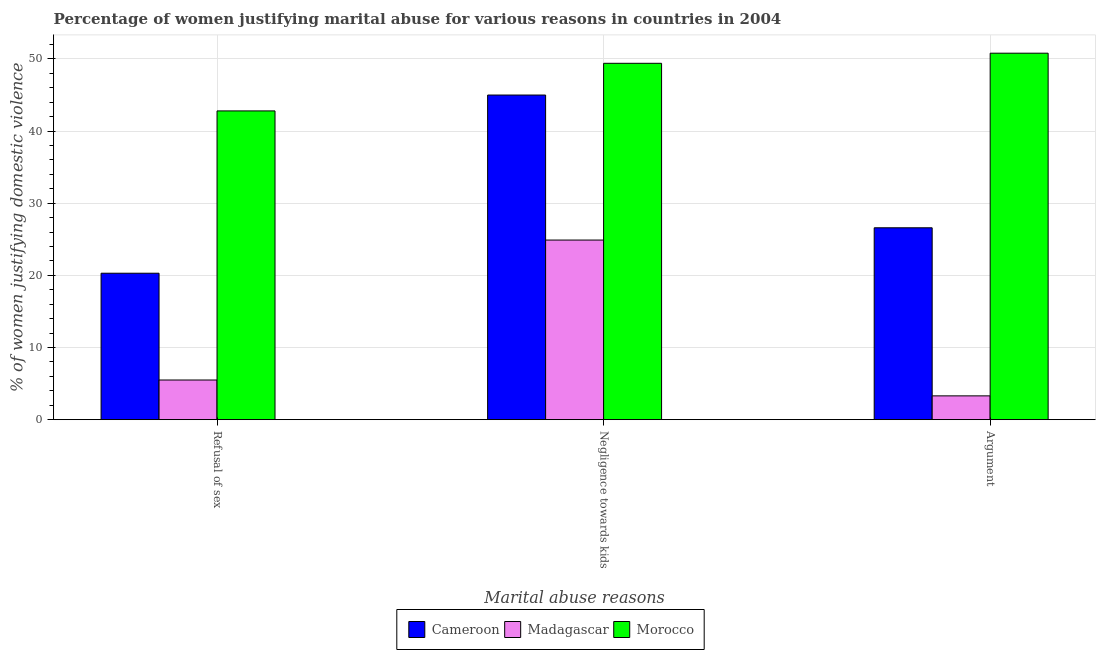How many different coloured bars are there?
Provide a short and direct response. 3. Are the number of bars on each tick of the X-axis equal?
Your answer should be very brief. Yes. How many bars are there on the 2nd tick from the left?
Your response must be concise. 3. How many bars are there on the 1st tick from the right?
Make the answer very short. 3. What is the label of the 2nd group of bars from the left?
Give a very brief answer. Negligence towards kids. What is the percentage of women justifying domestic violence due to arguments in Cameroon?
Your response must be concise. 26.6. Across all countries, what is the maximum percentage of women justifying domestic violence due to negligence towards kids?
Offer a terse response. 49.4. In which country was the percentage of women justifying domestic violence due to refusal of sex maximum?
Keep it short and to the point. Morocco. In which country was the percentage of women justifying domestic violence due to negligence towards kids minimum?
Offer a very short reply. Madagascar. What is the total percentage of women justifying domestic violence due to arguments in the graph?
Offer a terse response. 80.7. What is the difference between the percentage of women justifying domestic violence due to negligence towards kids in Madagascar and that in Cameroon?
Ensure brevity in your answer.  -20.1. What is the difference between the percentage of women justifying domestic violence due to refusal of sex in Cameroon and the percentage of women justifying domestic violence due to negligence towards kids in Madagascar?
Your answer should be compact. -4.6. What is the average percentage of women justifying domestic violence due to refusal of sex per country?
Give a very brief answer. 22.87. In how many countries, is the percentage of women justifying domestic violence due to negligence towards kids greater than 40 %?
Offer a very short reply. 2. What is the ratio of the percentage of women justifying domestic violence due to refusal of sex in Morocco to that in Cameroon?
Ensure brevity in your answer.  2.11. Is the difference between the percentage of women justifying domestic violence due to negligence towards kids in Madagascar and Morocco greater than the difference between the percentage of women justifying domestic violence due to arguments in Madagascar and Morocco?
Offer a terse response. Yes. What is the difference between the highest and the second highest percentage of women justifying domestic violence due to refusal of sex?
Your response must be concise. 22.5. In how many countries, is the percentage of women justifying domestic violence due to negligence towards kids greater than the average percentage of women justifying domestic violence due to negligence towards kids taken over all countries?
Your response must be concise. 2. What does the 1st bar from the left in Negligence towards kids represents?
Ensure brevity in your answer.  Cameroon. What does the 3rd bar from the right in Refusal of sex represents?
Provide a succinct answer. Cameroon. How many bars are there?
Ensure brevity in your answer.  9. Are all the bars in the graph horizontal?
Ensure brevity in your answer.  No. What is the difference between two consecutive major ticks on the Y-axis?
Provide a succinct answer. 10. Are the values on the major ticks of Y-axis written in scientific E-notation?
Offer a terse response. No. How many legend labels are there?
Give a very brief answer. 3. How are the legend labels stacked?
Your response must be concise. Horizontal. What is the title of the graph?
Your answer should be compact. Percentage of women justifying marital abuse for various reasons in countries in 2004. Does "Lao PDR" appear as one of the legend labels in the graph?
Your answer should be compact. No. What is the label or title of the X-axis?
Make the answer very short. Marital abuse reasons. What is the label or title of the Y-axis?
Your answer should be compact. % of women justifying domestic violence. What is the % of women justifying domestic violence of Cameroon in Refusal of sex?
Make the answer very short. 20.3. What is the % of women justifying domestic violence of Madagascar in Refusal of sex?
Your answer should be compact. 5.5. What is the % of women justifying domestic violence of Morocco in Refusal of sex?
Provide a succinct answer. 42.8. What is the % of women justifying domestic violence of Cameroon in Negligence towards kids?
Keep it short and to the point. 45. What is the % of women justifying domestic violence of Madagascar in Negligence towards kids?
Your response must be concise. 24.9. What is the % of women justifying domestic violence of Morocco in Negligence towards kids?
Your response must be concise. 49.4. What is the % of women justifying domestic violence in Cameroon in Argument?
Ensure brevity in your answer.  26.6. What is the % of women justifying domestic violence of Madagascar in Argument?
Your response must be concise. 3.3. What is the % of women justifying domestic violence of Morocco in Argument?
Provide a short and direct response. 50.8. Across all Marital abuse reasons, what is the maximum % of women justifying domestic violence of Cameroon?
Ensure brevity in your answer.  45. Across all Marital abuse reasons, what is the maximum % of women justifying domestic violence in Madagascar?
Ensure brevity in your answer.  24.9. Across all Marital abuse reasons, what is the maximum % of women justifying domestic violence of Morocco?
Give a very brief answer. 50.8. Across all Marital abuse reasons, what is the minimum % of women justifying domestic violence in Cameroon?
Make the answer very short. 20.3. Across all Marital abuse reasons, what is the minimum % of women justifying domestic violence of Morocco?
Keep it short and to the point. 42.8. What is the total % of women justifying domestic violence in Cameroon in the graph?
Your response must be concise. 91.9. What is the total % of women justifying domestic violence in Madagascar in the graph?
Your answer should be compact. 33.7. What is the total % of women justifying domestic violence in Morocco in the graph?
Provide a short and direct response. 143. What is the difference between the % of women justifying domestic violence of Cameroon in Refusal of sex and that in Negligence towards kids?
Provide a succinct answer. -24.7. What is the difference between the % of women justifying domestic violence in Madagascar in Refusal of sex and that in Negligence towards kids?
Ensure brevity in your answer.  -19.4. What is the difference between the % of women justifying domestic violence of Morocco in Refusal of sex and that in Negligence towards kids?
Keep it short and to the point. -6.6. What is the difference between the % of women justifying domestic violence of Cameroon in Refusal of sex and that in Argument?
Provide a short and direct response. -6.3. What is the difference between the % of women justifying domestic violence in Madagascar in Negligence towards kids and that in Argument?
Provide a succinct answer. 21.6. What is the difference between the % of women justifying domestic violence in Morocco in Negligence towards kids and that in Argument?
Your answer should be very brief. -1.4. What is the difference between the % of women justifying domestic violence in Cameroon in Refusal of sex and the % of women justifying domestic violence in Morocco in Negligence towards kids?
Your response must be concise. -29.1. What is the difference between the % of women justifying domestic violence of Madagascar in Refusal of sex and the % of women justifying domestic violence of Morocco in Negligence towards kids?
Offer a terse response. -43.9. What is the difference between the % of women justifying domestic violence in Cameroon in Refusal of sex and the % of women justifying domestic violence in Madagascar in Argument?
Your response must be concise. 17. What is the difference between the % of women justifying domestic violence in Cameroon in Refusal of sex and the % of women justifying domestic violence in Morocco in Argument?
Keep it short and to the point. -30.5. What is the difference between the % of women justifying domestic violence in Madagascar in Refusal of sex and the % of women justifying domestic violence in Morocco in Argument?
Your response must be concise. -45.3. What is the difference between the % of women justifying domestic violence in Cameroon in Negligence towards kids and the % of women justifying domestic violence in Madagascar in Argument?
Offer a very short reply. 41.7. What is the difference between the % of women justifying domestic violence in Madagascar in Negligence towards kids and the % of women justifying domestic violence in Morocco in Argument?
Offer a very short reply. -25.9. What is the average % of women justifying domestic violence of Cameroon per Marital abuse reasons?
Your answer should be compact. 30.63. What is the average % of women justifying domestic violence in Madagascar per Marital abuse reasons?
Offer a terse response. 11.23. What is the average % of women justifying domestic violence of Morocco per Marital abuse reasons?
Make the answer very short. 47.67. What is the difference between the % of women justifying domestic violence in Cameroon and % of women justifying domestic violence in Madagascar in Refusal of sex?
Keep it short and to the point. 14.8. What is the difference between the % of women justifying domestic violence of Cameroon and % of women justifying domestic violence of Morocco in Refusal of sex?
Your answer should be very brief. -22.5. What is the difference between the % of women justifying domestic violence of Madagascar and % of women justifying domestic violence of Morocco in Refusal of sex?
Provide a succinct answer. -37.3. What is the difference between the % of women justifying domestic violence of Cameroon and % of women justifying domestic violence of Madagascar in Negligence towards kids?
Keep it short and to the point. 20.1. What is the difference between the % of women justifying domestic violence of Cameroon and % of women justifying domestic violence of Morocco in Negligence towards kids?
Provide a succinct answer. -4.4. What is the difference between the % of women justifying domestic violence of Madagascar and % of women justifying domestic violence of Morocco in Negligence towards kids?
Keep it short and to the point. -24.5. What is the difference between the % of women justifying domestic violence of Cameroon and % of women justifying domestic violence of Madagascar in Argument?
Offer a very short reply. 23.3. What is the difference between the % of women justifying domestic violence in Cameroon and % of women justifying domestic violence in Morocco in Argument?
Offer a terse response. -24.2. What is the difference between the % of women justifying domestic violence of Madagascar and % of women justifying domestic violence of Morocco in Argument?
Your answer should be very brief. -47.5. What is the ratio of the % of women justifying domestic violence in Cameroon in Refusal of sex to that in Negligence towards kids?
Keep it short and to the point. 0.45. What is the ratio of the % of women justifying domestic violence in Madagascar in Refusal of sex to that in Negligence towards kids?
Your answer should be compact. 0.22. What is the ratio of the % of women justifying domestic violence in Morocco in Refusal of sex to that in Negligence towards kids?
Your answer should be compact. 0.87. What is the ratio of the % of women justifying domestic violence of Cameroon in Refusal of sex to that in Argument?
Offer a terse response. 0.76. What is the ratio of the % of women justifying domestic violence of Morocco in Refusal of sex to that in Argument?
Keep it short and to the point. 0.84. What is the ratio of the % of women justifying domestic violence in Cameroon in Negligence towards kids to that in Argument?
Your answer should be compact. 1.69. What is the ratio of the % of women justifying domestic violence of Madagascar in Negligence towards kids to that in Argument?
Ensure brevity in your answer.  7.55. What is the ratio of the % of women justifying domestic violence in Morocco in Negligence towards kids to that in Argument?
Provide a short and direct response. 0.97. What is the difference between the highest and the second highest % of women justifying domestic violence of Cameroon?
Provide a succinct answer. 18.4. What is the difference between the highest and the lowest % of women justifying domestic violence in Cameroon?
Offer a very short reply. 24.7. What is the difference between the highest and the lowest % of women justifying domestic violence in Madagascar?
Provide a succinct answer. 21.6. What is the difference between the highest and the lowest % of women justifying domestic violence of Morocco?
Make the answer very short. 8. 